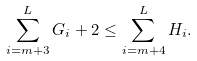<formula> <loc_0><loc_0><loc_500><loc_500>\sum _ { i = m + 3 } ^ { L } G _ { i } + 2 \leq \sum _ { i = m + 4 } ^ { L } H _ { i } .</formula> 